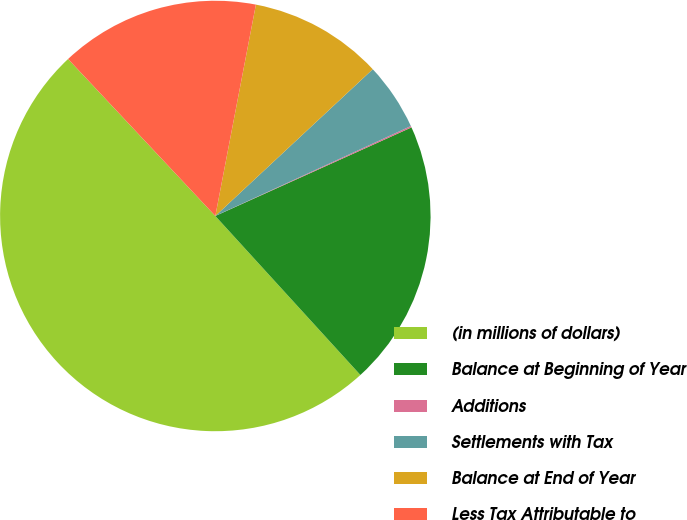Convert chart to OTSL. <chart><loc_0><loc_0><loc_500><loc_500><pie_chart><fcel>(in millions of dollars)<fcel>Balance at Beginning of Year<fcel>Additions<fcel>Settlements with Tax<fcel>Balance at End of Year<fcel>Less Tax Attributable to<nl><fcel>49.78%<fcel>19.98%<fcel>0.11%<fcel>5.08%<fcel>10.04%<fcel>15.01%<nl></chart> 